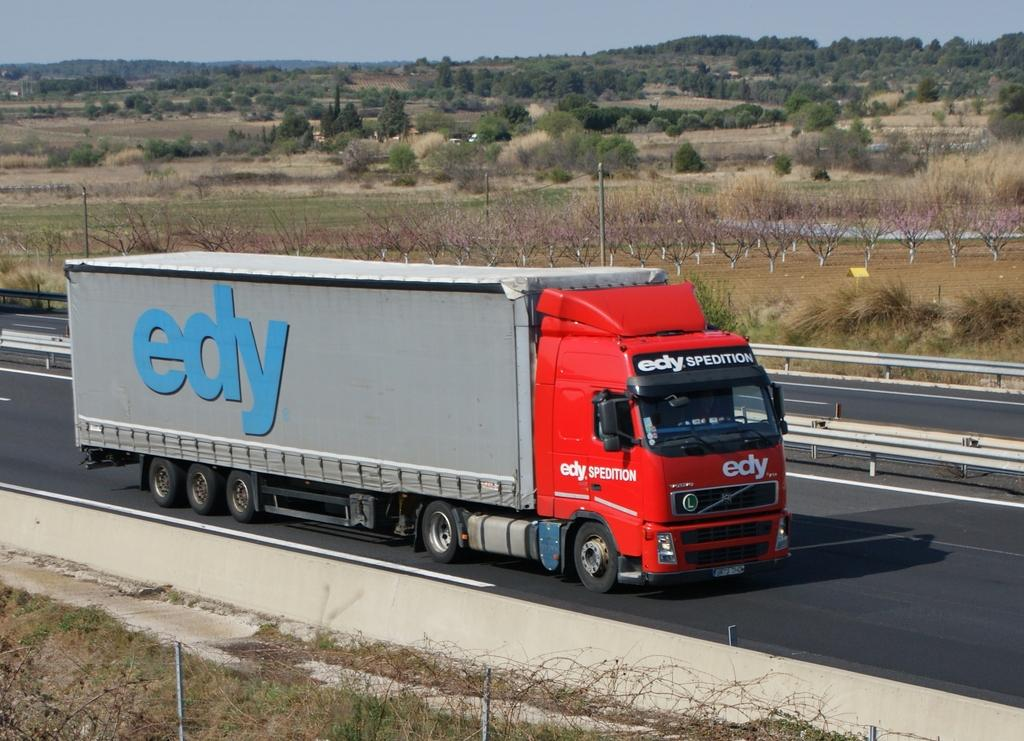What is the main subject of the image? The main subject of the image is a big truck. What is the truck doing in the image? The truck is riding on the road in the image. What can be seen in the background of the image? There is a fence and a waste land with many trees and grass in the background. What type of spring is visible in the image? There is no spring present in the image; it features a big truck riding on the road and a waste land in the background. 